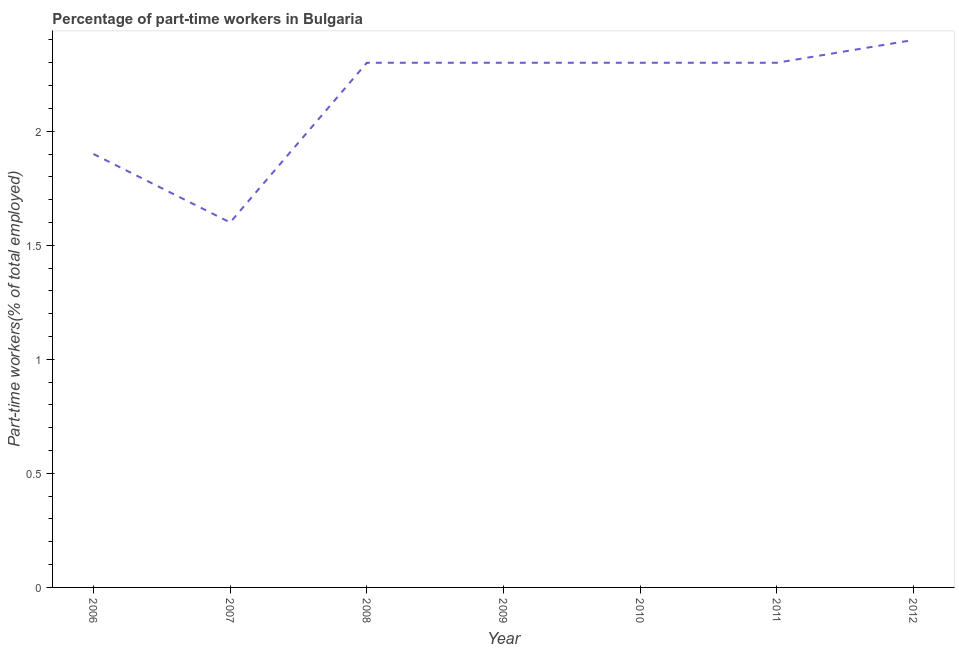What is the percentage of part-time workers in 2006?
Ensure brevity in your answer.  1.9. Across all years, what is the maximum percentage of part-time workers?
Offer a terse response. 2.4. Across all years, what is the minimum percentage of part-time workers?
Your answer should be very brief. 1.6. What is the sum of the percentage of part-time workers?
Your response must be concise. 15.1. What is the difference between the percentage of part-time workers in 2007 and 2008?
Offer a very short reply. -0.7. What is the average percentage of part-time workers per year?
Provide a succinct answer. 2.16. What is the median percentage of part-time workers?
Make the answer very short. 2.3. In how many years, is the percentage of part-time workers greater than 0.4 %?
Your answer should be compact. 7. Do a majority of the years between 2010 and 2011 (inclusive) have percentage of part-time workers greater than 1.5 %?
Offer a very short reply. Yes. What is the ratio of the percentage of part-time workers in 2006 to that in 2010?
Your response must be concise. 0.83. What is the difference between the highest and the second highest percentage of part-time workers?
Give a very brief answer. 0.1. Is the sum of the percentage of part-time workers in 2010 and 2012 greater than the maximum percentage of part-time workers across all years?
Keep it short and to the point. Yes. What is the difference between the highest and the lowest percentage of part-time workers?
Make the answer very short. 0.8. Does the percentage of part-time workers monotonically increase over the years?
Provide a succinct answer. No. How many lines are there?
Offer a terse response. 1. How many years are there in the graph?
Your answer should be compact. 7. What is the difference between two consecutive major ticks on the Y-axis?
Offer a very short reply. 0.5. Does the graph contain grids?
Keep it short and to the point. No. What is the title of the graph?
Your answer should be compact. Percentage of part-time workers in Bulgaria. What is the label or title of the X-axis?
Your answer should be compact. Year. What is the label or title of the Y-axis?
Your response must be concise. Part-time workers(% of total employed). What is the Part-time workers(% of total employed) in 2006?
Offer a very short reply. 1.9. What is the Part-time workers(% of total employed) of 2007?
Offer a very short reply. 1.6. What is the Part-time workers(% of total employed) of 2008?
Offer a very short reply. 2.3. What is the Part-time workers(% of total employed) of 2009?
Offer a terse response. 2.3. What is the Part-time workers(% of total employed) of 2010?
Provide a succinct answer. 2.3. What is the Part-time workers(% of total employed) of 2011?
Make the answer very short. 2.3. What is the Part-time workers(% of total employed) in 2012?
Provide a succinct answer. 2.4. What is the difference between the Part-time workers(% of total employed) in 2006 and 2009?
Provide a succinct answer. -0.4. What is the difference between the Part-time workers(% of total employed) in 2006 and 2011?
Offer a very short reply. -0.4. What is the difference between the Part-time workers(% of total employed) in 2006 and 2012?
Offer a very short reply. -0.5. What is the difference between the Part-time workers(% of total employed) in 2007 and 2010?
Give a very brief answer. -0.7. What is the difference between the Part-time workers(% of total employed) in 2007 and 2011?
Your answer should be very brief. -0.7. What is the difference between the Part-time workers(% of total employed) in 2008 and 2010?
Offer a very short reply. 0. What is the difference between the Part-time workers(% of total employed) in 2008 and 2011?
Make the answer very short. 0. What is the difference between the Part-time workers(% of total employed) in 2008 and 2012?
Provide a short and direct response. -0.1. What is the difference between the Part-time workers(% of total employed) in 2009 and 2010?
Give a very brief answer. 0. What is the difference between the Part-time workers(% of total employed) in 2009 and 2011?
Offer a very short reply. 0. What is the difference between the Part-time workers(% of total employed) in 2011 and 2012?
Your response must be concise. -0.1. What is the ratio of the Part-time workers(% of total employed) in 2006 to that in 2007?
Your response must be concise. 1.19. What is the ratio of the Part-time workers(% of total employed) in 2006 to that in 2008?
Your response must be concise. 0.83. What is the ratio of the Part-time workers(% of total employed) in 2006 to that in 2009?
Ensure brevity in your answer.  0.83. What is the ratio of the Part-time workers(% of total employed) in 2006 to that in 2010?
Give a very brief answer. 0.83. What is the ratio of the Part-time workers(% of total employed) in 2006 to that in 2011?
Ensure brevity in your answer.  0.83. What is the ratio of the Part-time workers(% of total employed) in 2006 to that in 2012?
Your answer should be very brief. 0.79. What is the ratio of the Part-time workers(% of total employed) in 2007 to that in 2008?
Keep it short and to the point. 0.7. What is the ratio of the Part-time workers(% of total employed) in 2007 to that in 2009?
Keep it short and to the point. 0.7. What is the ratio of the Part-time workers(% of total employed) in 2007 to that in 2010?
Offer a very short reply. 0.7. What is the ratio of the Part-time workers(% of total employed) in 2007 to that in 2011?
Ensure brevity in your answer.  0.7. What is the ratio of the Part-time workers(% of total employed) in 2007 to that in 2012?
Provide a short and direct response. 0.67. What is the ratio of the Part-time workers(% of total employed) in 2008 to that in 2009?
Keep it short and to the point. 1. What is the ratio of the Part-time workers(% of total employed) in 2008 to that in 2011?
Give a very brief answer. 1. What is the ratio of the Part-time workers(% of total employed) in 2008 to that in 2012?
Make the answer very short. 0.96. What is the ratio of the Part-time workers(% of total employed) in 2009 to that in 2010?
Your answer should be compact. 1. What is the ratio of the Part-time workers(% of total employed) in 2009 to that in 2012?
Provide a succinct answer. 0.96. What is the ratio of the Part-time workers(% of total employed) in 2010 to that in 2012?
Your answer should be compact. 0.96. What is the ratio of the Part-time workers(% of total employed) in 2011 to that in 2012?
Give a very brief answer. 0.96. 